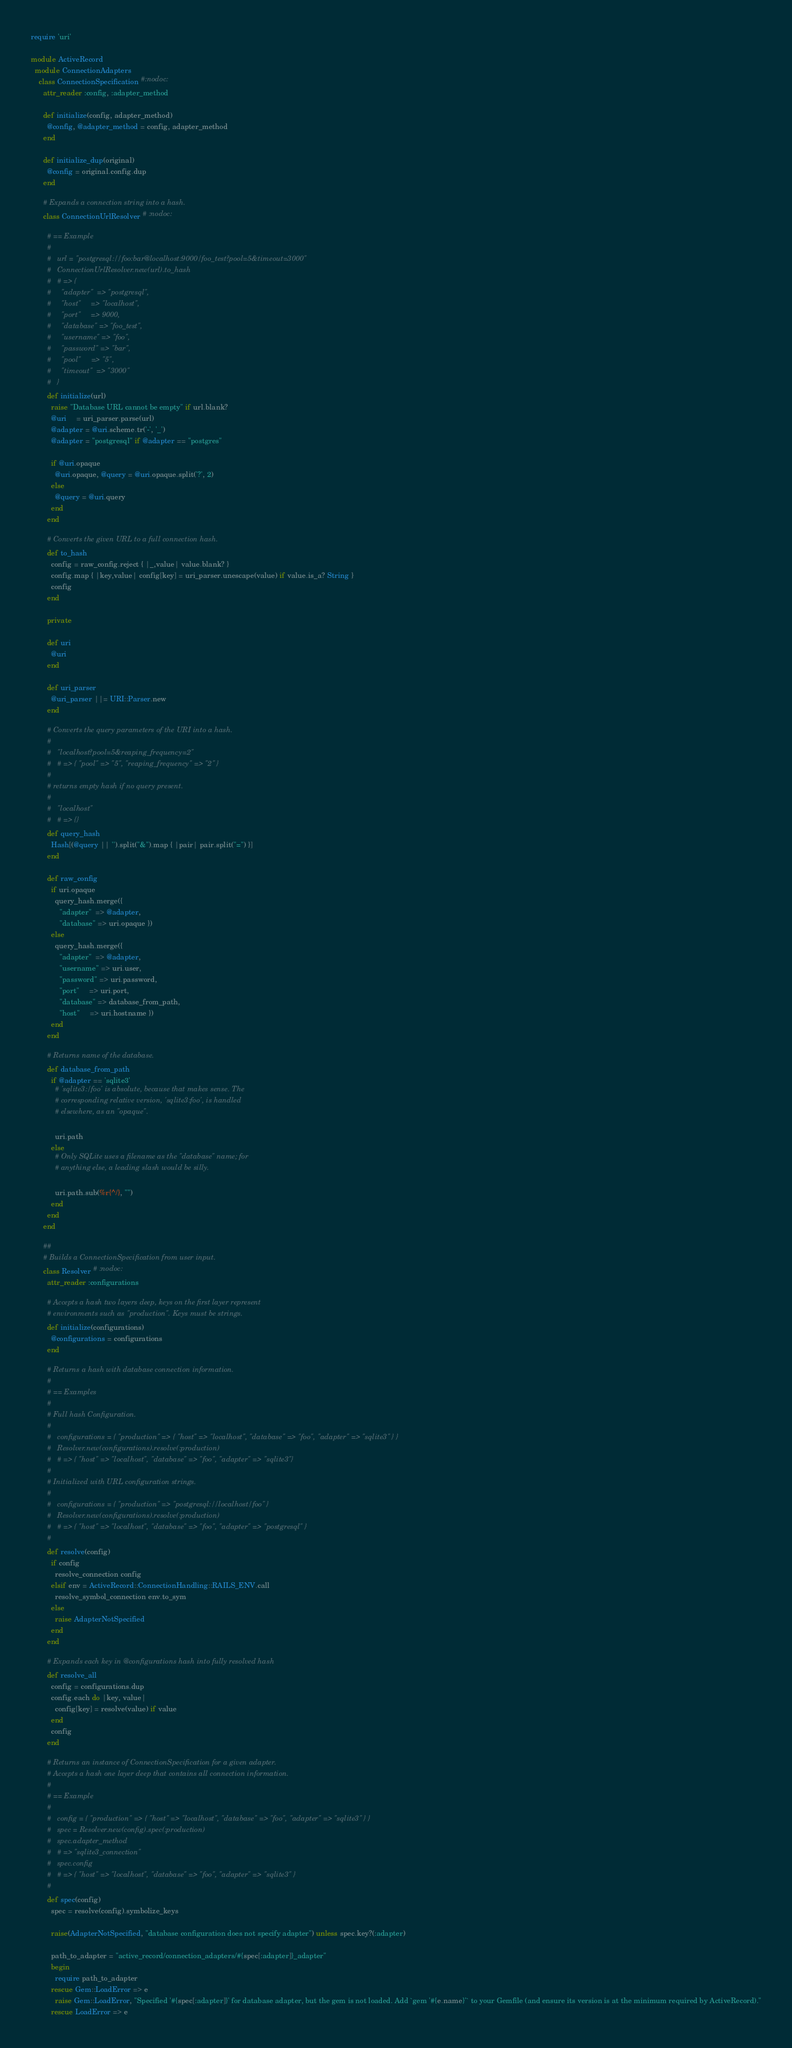<code> <loc_0><loc_0><loc_500><loc_500><_Ruby_>require 'uri'

module ActiveRecord
  module ConnectionAdapters
    class ConnectionSpecification #:nodoc:
      attr_reader :config, :adapter_method

      def initialize(config, adapter_method)
        @config, @adapter_method = config, adapter_method
      end

      def initialize_dup(original)
        @config = original.config.dup
      end

      # Expands a connection string into a hash.
      class ConnectionUrlResolver # :nodoc:

        # == Example
        #
        #   url = "postgresql://foo:bar@localhost:9000/foo_test?pool=5&timeout=3000"
        #   ConnectionUrlResolver.new(url).to_hash
        #   # => {
        #     "adapter"  => "postgresql",
        #     "host"     => "localhost",
        #     "port"     => 9000,
        #     "database" => "foo_test",
        #     "username" => "foo",
        #     "password" => "bar",
        #     "pool"     => "5",
        #     "timeout"  => "3000"
        #   }
        def initialize(url)
          raise "Database URL cannot be empty" if url.blank?
          @uri     = uri_parser.parse(url)
          @adapter = @uri.scheme.tr('-', '_')
          @adapter = "postgresql" if @adapter == "postgres"

          if @uri.opaque
            @uri.opaque, @query = @uri.opaque.split('?', 2)
          else
            @query = @uri.query
          end
        end

        # Converts the given URL to a full connection hash.
        def to_hash
          config = raw_config.reject { |_,value| value.blank? }
          config.map { |key,value| config[key] = uri_parser.unescape(value) if value.is_a? String }
          config
        end

        private

        def uri
          @uri
        end

        def uri_parser
          @uri_parser ||= URI::Parser.new
        end

        # Converts the query parameters of the URI into a hash.
        #
        #   "localhost?pool=5&reaping_frequency=2"
        #   # => { "pool" => "5", "reaping_frequency" => "2" }
        #
        # returns empty hash if no query present.
        #
        #   "localhost"
        #   # => {}
        def query_hash
          Hash[(@query || '').split("&").map { |pair| pair.split("=") }]
        end

        def raw_config
          if uri.opaque
            query_hash.merge({
              "adapter"  => @adapter,
              "database" => uri.opaque })
          else
            query_hash.merge({
              "adapter"  => @adapter,
              "username" => uri.user,
              "password" => uri.password,
              "port"     => uri.port,
              "database" => database_from_path,
              "host"     => uri.hostname })
          end
        end

        # Returns name of the database.
        def database_from_path
          if @adapter == 'sqlite3'
            # 'sqlite3:/foo' is absolute, because that makes sense. The
            # corresponding relative version, 'sqlite3:foo', is handled
            # elsewhere, as an "opaque".

            uri.path
          else
            # Only SQLite uses a filename as the "database" name; for
            # anything else, a leading slash would be silly.

            uri.path.sub(%r{^/}, "")
          end
        end
      end

      ##
      # Builds a ConnectionSpecification from user input.
      class Resolver # :nodoc:
        attr_reader :configurations

        # Accepts a hash two layers deep, keys on the first layer represent
        # environments such as "production". Keys must be strings.
        def initialize(configurations)
          @configurations = configurations
        end

        # Returns a hash with database connection information.
        #
        # == Examples
        #
        # Full hash Configuration.
        #
        #   configurations = { "production" => { "host" => "localhost", "database" => "foo", "adapter" => "sqlite3" } }
        #   Resolver.new(configurations).resolve(:production)
        #   # => { "host" => "localhost", "database" => "foo", "adapter" => "sqlite3"}
        #
        # Initialized with URL configuration strings.
        #
        #   configurations = { "production" => "postgresql://localhost/foo" }
        #   Resolver.new(configurations).resolve(:production)
        #   # => { "host" => "localhost", "database" => "foo", "adapter" => "postgresql" }
        #
        def resolve(config)
          if config
            resolve_connection config
          elsif env = ActiveRecord::ConnectionHandling::RAILS_ENV.call
            resolve_symbol_connection env.to_sym
          else
            raise AdapterNotSpecified
          end
        end

        # Expands each key in @configurations hash into fully resolved hash
        def resolve_all
          config = configurations.dup
          config.each do |key, value|
            config[key] = resolve(value) if value
          end
          config
        end

        # Returns an instance of ConnectionSpecification for a given adapter.
        # Accepts a hash one layer deep that contains all connection information.
        #
        # == Example
        #
        #   config = { "production" => { "host" => "localhost", "database" => "foo", "adapter" => "sqlite3" } }
        #   spec = Resolver.new(config).spec(:production)
        #   spec.adapter_method
        #   # => "sqlite3_connection"
        #   spec.config
        #   # => { "host" => "localhost", "database" => "foo", "adapter" => "sqlite3" }
        #
        def spec(config)
          spec = resolve(config).symbolize_keys

          raise(AdapterNotSpecified, "database configuration does not specify adapter") unless spec.key?(:adapter)

          path_to_adapter = "active_record/connection_adapters/#{spec[:adapter]}_adapter"
          begin
            require path_to_adapter
          rescue Gem::LoadError => e
            raise Gem::LoadError, "Specified '#{spec[:adapter]}' for database adapter, but the gem is not loaded. Add `gem '#{e.name}'` to your Gemfile (and ensure its version is at the minimum required by ActiveRecord)."
          rescue LoadError => e</code> 